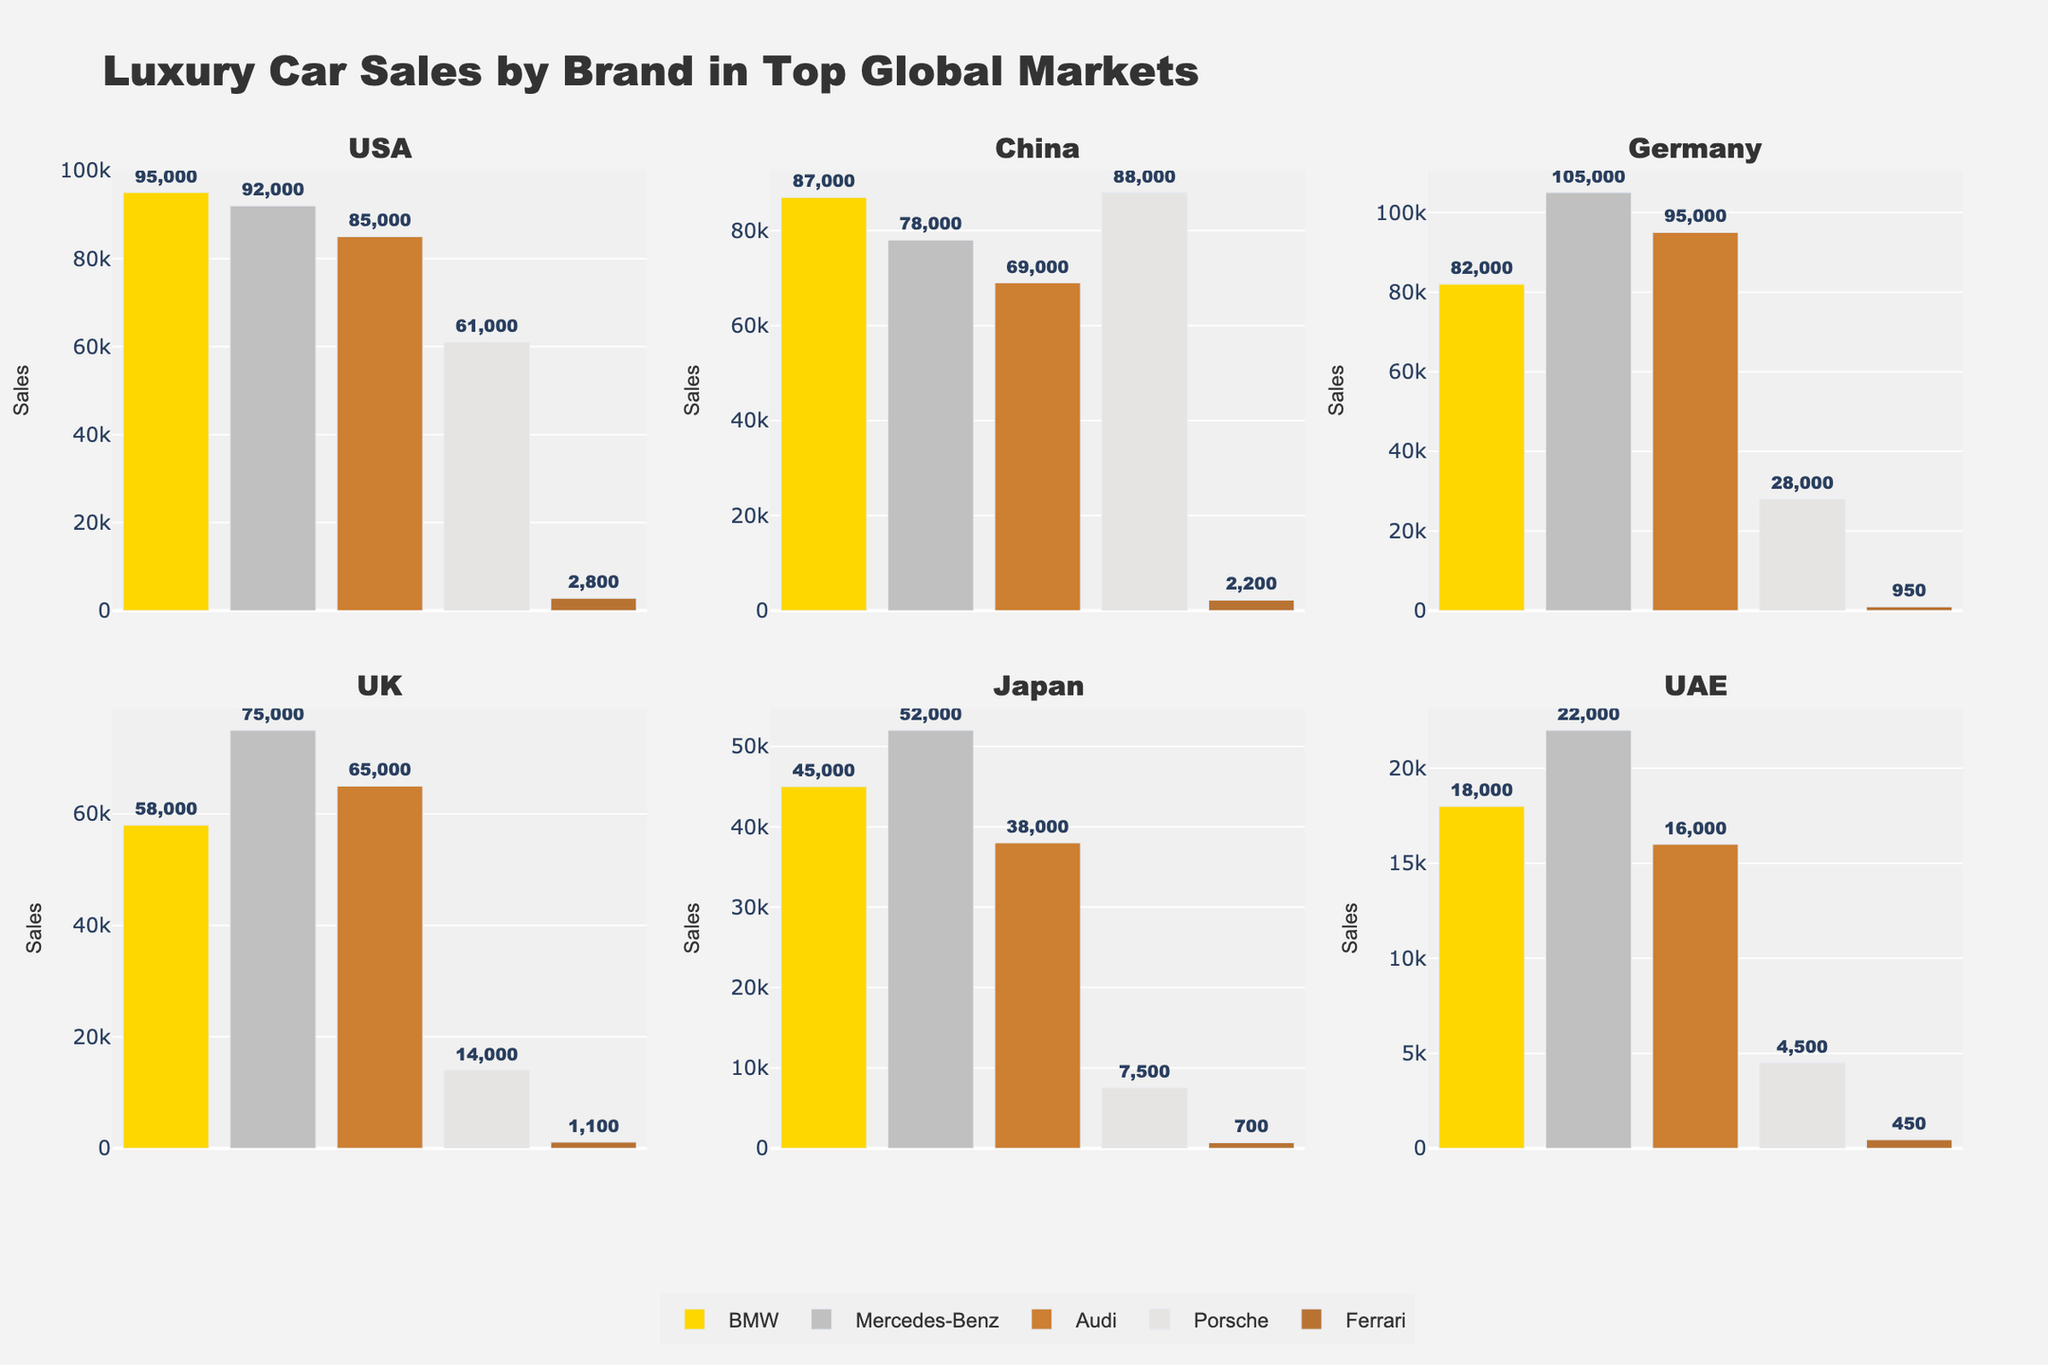What is the title of the figure? The title is displayed at the top of the figure in a larger font. It helps to identify what the figure is about.
Answer: Luxury Car Sales by Brand in Top Global Markets Which market has the highest BMW sales? Look at the bar corresponding to BMW in each subplot and compare their heights. The tallest bar indicates the highest sales.
Answer: USA Which brand has the lowest sales in Germany? Look at the subplot titled "Germany" and compare the height of the bars for each brand. The shortest bar corresponds to the lowest sales.
Answer: Ferrari How many brands are shown in each subplot? Each subplot presents bars for different brands. Count the number of bars in any single subplot.
Answer: 5 What is the total sales for Porsche in the USA and China combined? Locate the bars for Porsche in the USA and China subplots, add their sales figures together. (61000 from USA + 88000 from China)
Answer: 149000 In which market does Mercedes-Benz outsell BMW? Compare the heights of the bars labeled Mercedes-Benz and BMW in each subplot. Identify the subplot where the Mercedes-Benz bar is higher.
Answer: Germany Which market shows the lowest overall sales across all brands? Compare the total heights of all bars in each subplot. Identify the subplot with the lowest sum of bar heights.
Answer: UAE What is the sales difference between Audi and Porsche in Japan? Look at the bars for Audi and Porsche in the Japan subplot and find their sales figures. Subtract the lower figure from the higher one. (38000 - 7500)
Answer: 30500 Which brand has its highest sales in the UK? Find the tallest bar in the UK subplot and note which brand it corresponds to.
Answer: Mercedes-Benz How do Porsche sales in the USA compare to its sales in Japan? Find the height of the Porsche bars in the USA and Japan subplots. Note the sales figures and compare them.
Answer: Higher in USA 